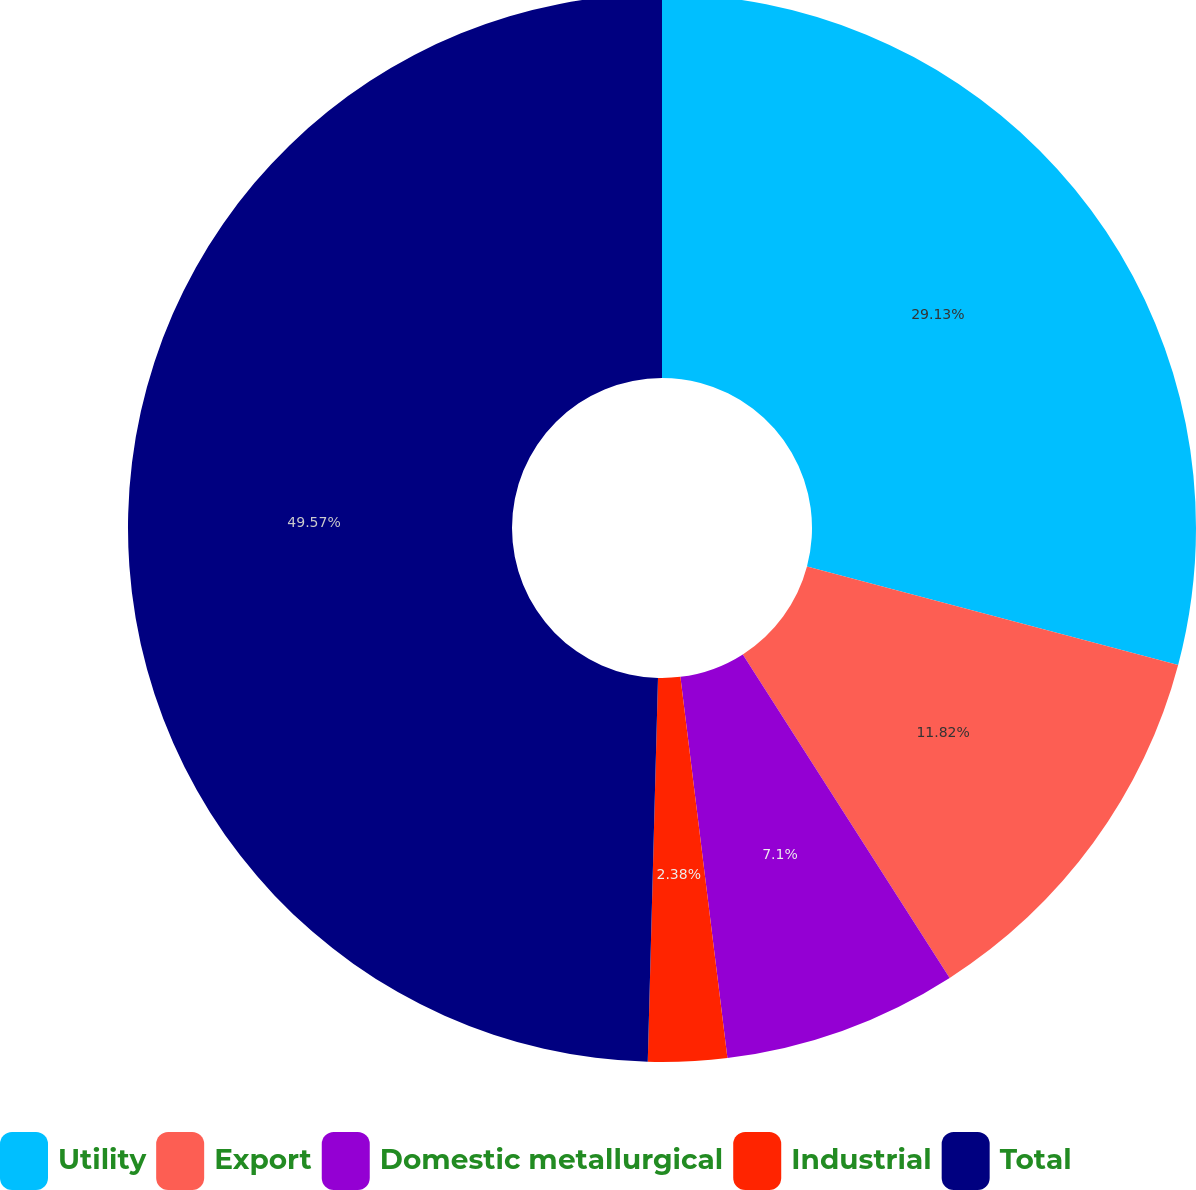Convert chart to OTSL. <chart><loc_0><loc_0><loc_500><loc_500><pie_chart><fcel>Utility<fcel>Export<fcel>Domestic metallurgical<fcel>Industrial<fcel>Total<nl><fcel>29.13%<fcel>11.82%<fcel>7.1%<fcel>2.38%<fcel>49.58%<nl></chart> 